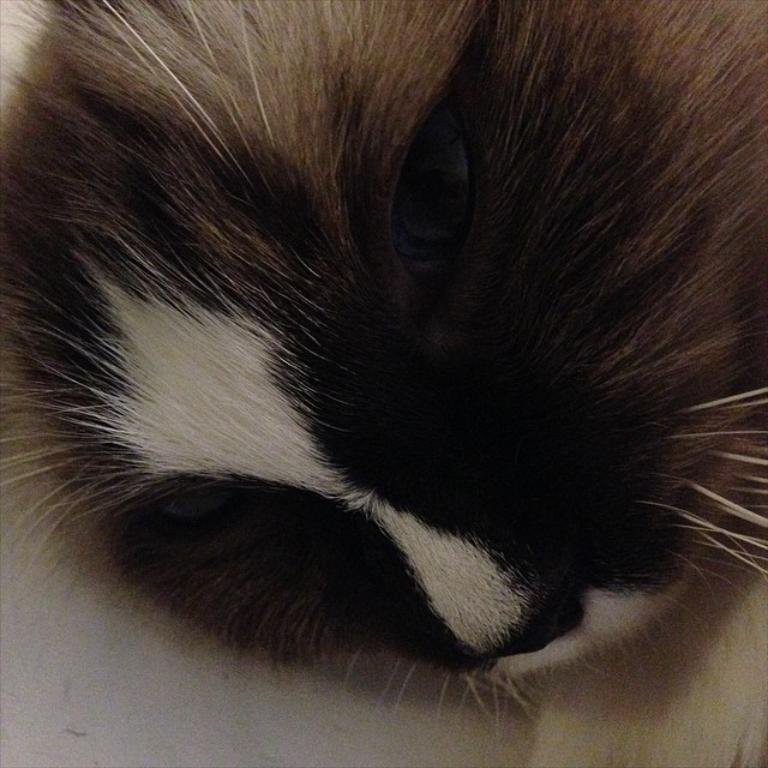What is the main subject of the image? The main subject of the image is a cat. Can you describe the cat in the image? The image is a zoomed-in picture of a cat, so we cannot see the entire cat, but we can see its features in detail. What type of peace symbol can be seen in the image? There is no peace symbol present in the image; it is a zoomed-in picture of a cat. 